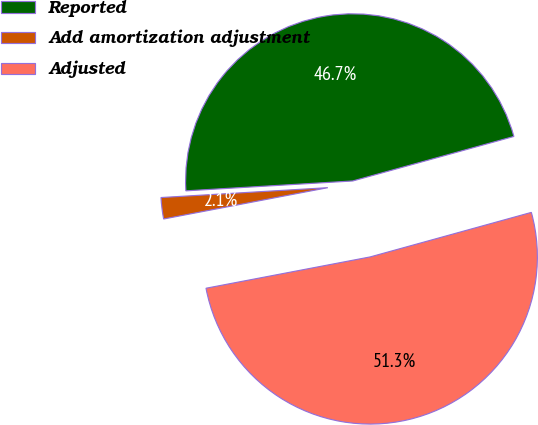Convert chart. <chart><loc_0><loc_0><loc_500><loc_500><pie_chart><fcel>Reported<fcel>Add amortization adjustment<fcel>Adjusted<nl><fcel>46.65%<fcel>2.06%<fcel>51.29%<nl></chart> 